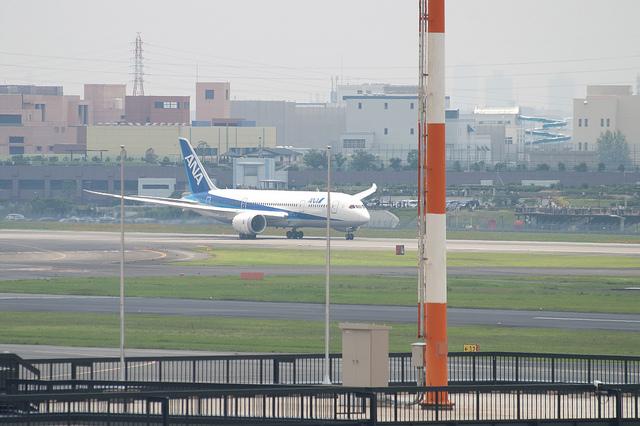Why is the pole in front striped orange and white?
Keep it brief. Visibility. What is written on the tail of the airplane?
Keep it brief. Ana. Is the plane landing?
Short answer required. Yes. 